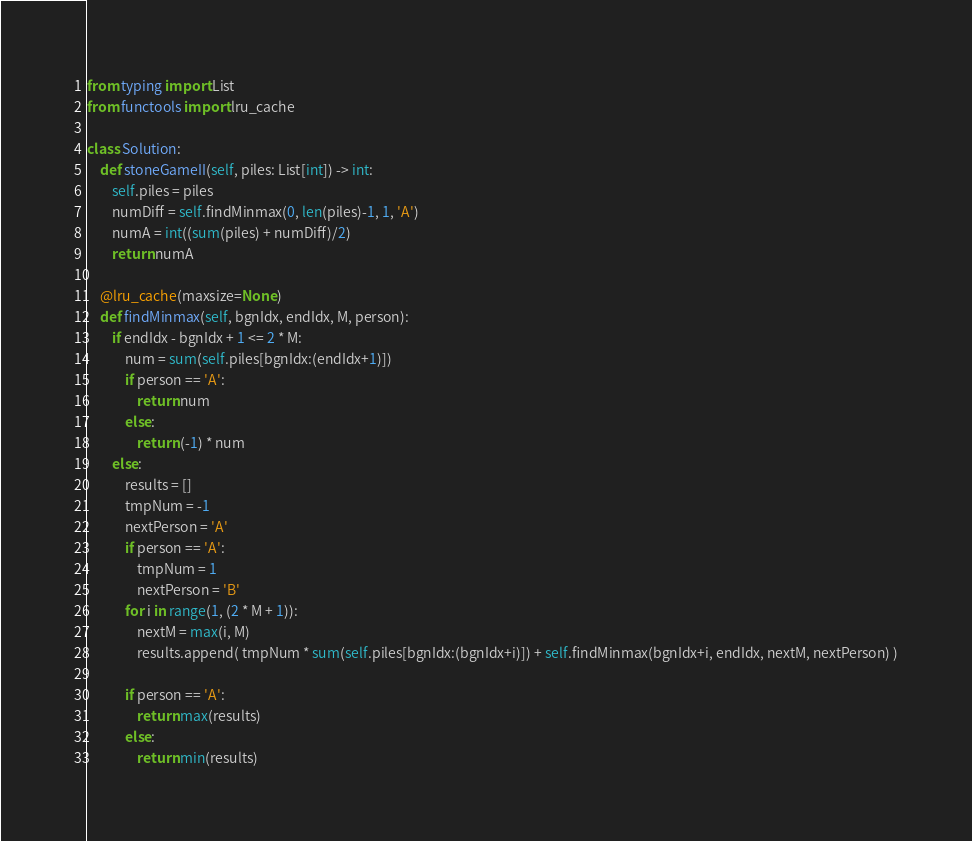Convert code to text. <code><loc_0><loc_0><loc_500><loc_500><_Python_>from typing import List
from functools import lru_cache

class Solution:
    def stoneGameII(self, piles: List[int]) -> int:
        self.piles = piles
        numDiff = self.findMinmax(0, len(piles)-1, 1, 'A')
        numA = int((sum(piles) + numDiff)/2)
        return numA

    @lru_cache(maxsize=None)
    def findMinmax(self, bgnIdx, endIdx, M, person):
        if endIdx - bgnIdx + 1 <= 2 * M:
            num = sum(self.piles[bgnIdx:(endIdx+1)])
            if person == 'A':
                return num
            else:
                return (-1) * num
        else:
            results = []
            tmpNum = -1
            nextPerson = 'A'
            if person == 'A':
                tmpNum = 1
                nextPerson = 'B'
            for i in range(1, (2 * M + 1)):
                nextM = max(i, M)
                results.append( tmpNum * sum(self.piles[bgnIdx:(bgnIdx+i)]) + self.findMinmax(bgnIdx+i, endIdx, nextM, nextPerson) )

            if person == 'A':
                return max(results)
            else:
                return min(results)

</code> 